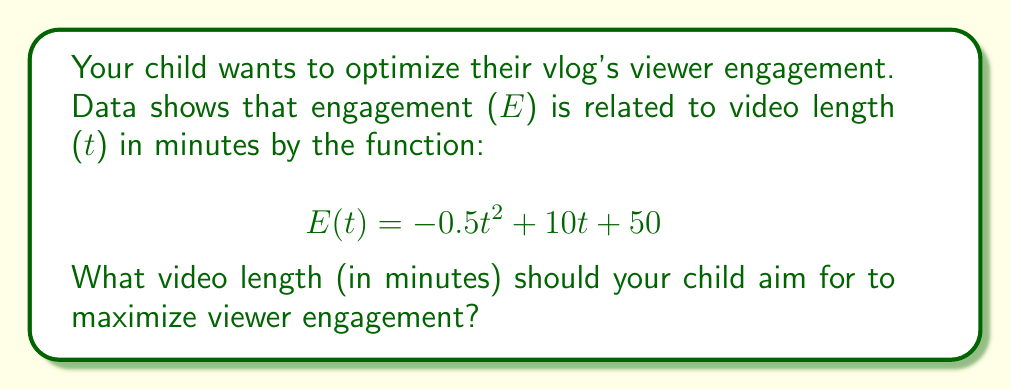Can you answer this question? To find the optimal video length for maximum viewer engagement, we need to find the maximum point of the quadratic function $E(t)$.

1. The function $E(t) = -0.5t^2 + 10t + 50$ is a quadratic function in the form $f(t) = at^2 + bt + c$, where:
   $a = -0.5$, $b = 10$, and $c = 50$

2. For a quadratic function, the t-coordinate of the vertex (which gives the maximum point for a downward-facing parabola) is given by the formula:

   $$t = -\frac{b}{2a}$$

3. Substituting our values:

   $$t = -\frac{10}{2(-0.5)} = -\frac{10}{-1} = 10$$

4. To verify this is a maximum, we can check that $a < 0$ (which it is: $a = -0.5$).

5. Therefore, the optimal video length for maximum viewer engagement is 10 minutes.

To find the maximum engagement value:
$$E(10) = -0.5(10)^2 + 10(10) + 50 = -50 + 100 + 50 = 100$$

So, the maximum engagement value is 100 units.
Answer: The optimal video length for maximum viewer engagement is 10 minutes. 